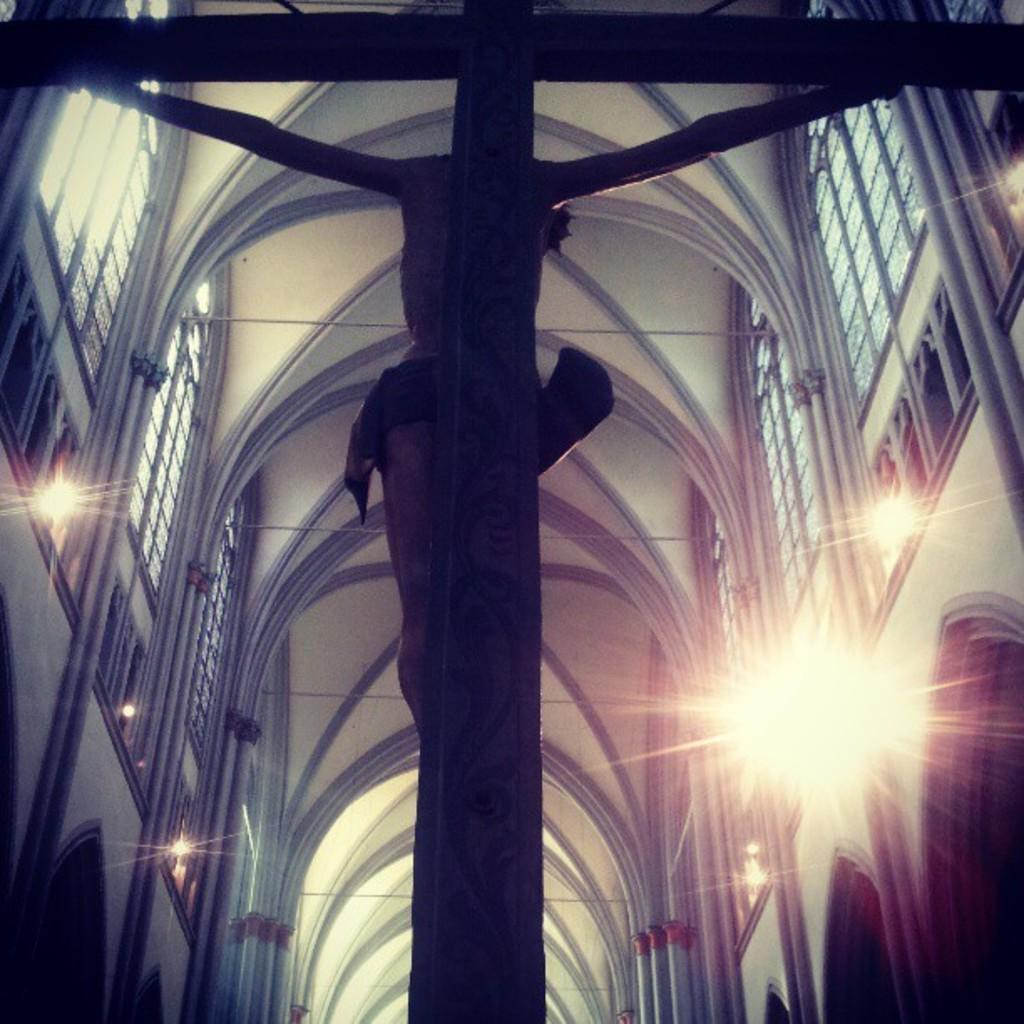What type of building is shown in the image? The image shows an inside view of a church. What religious symbol can be seen in the image? There is a cross visible in the image. What type of windows are present in the church? There are walls with glass windows in the image. What is placed inside the windows? Glasses are present in the windows. What can be seen providing illumination in the image? Lights are visible in the image. Who is giving the haircut to the aunt in the image? There is no haircut or aunt present in the image; it shows an inside view of a church. Who is the owner of the church in the image? The image does not provide information about the ownership of the church. 